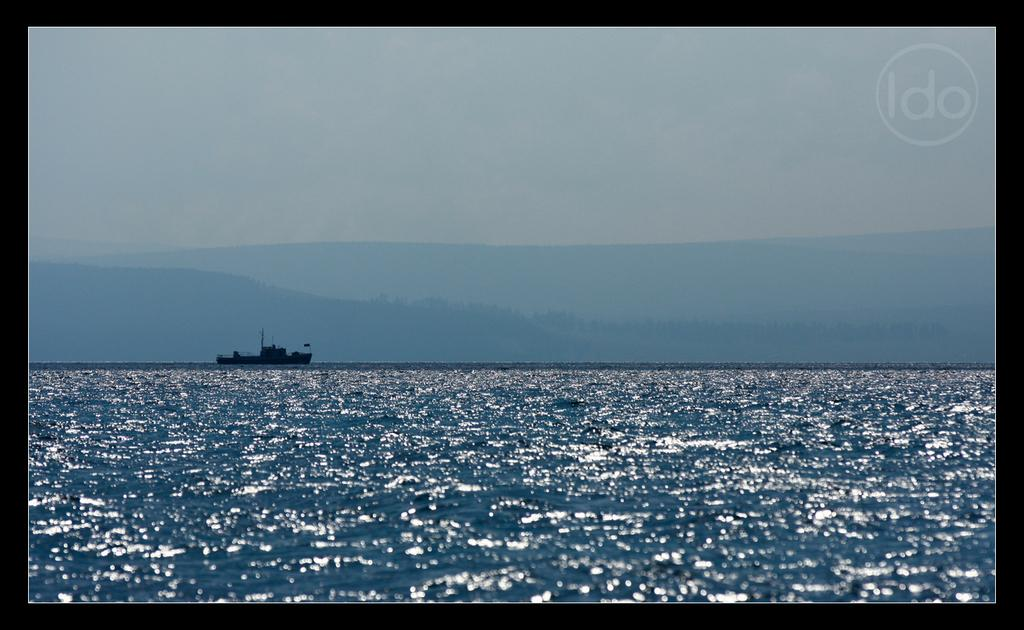What is in the foreground of the image? There is a water surface in the foreground of the image. What can be seen in the image besides the water surface? There is a ship in the image. What type of landscape can be seen in the background of the image? It appears that there are mountains in the background of the image. What else is visible in the background of the image? The sky is visible in the background of the image. What type of wall can be seen in the image? There is no wall present in the image. Is it raining in the image? There is no indication of rain in the image; it only shows a water surface, a ship, mountains, and the sky. 